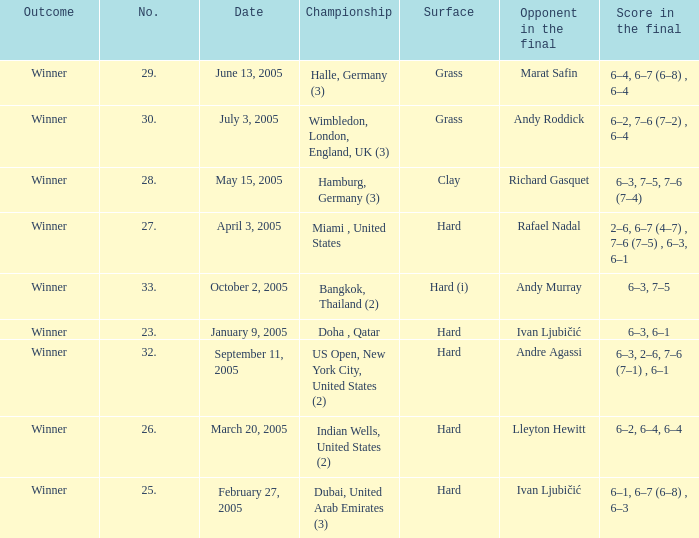Andy Roddick is the opponent in the final on what surface? Grass. 